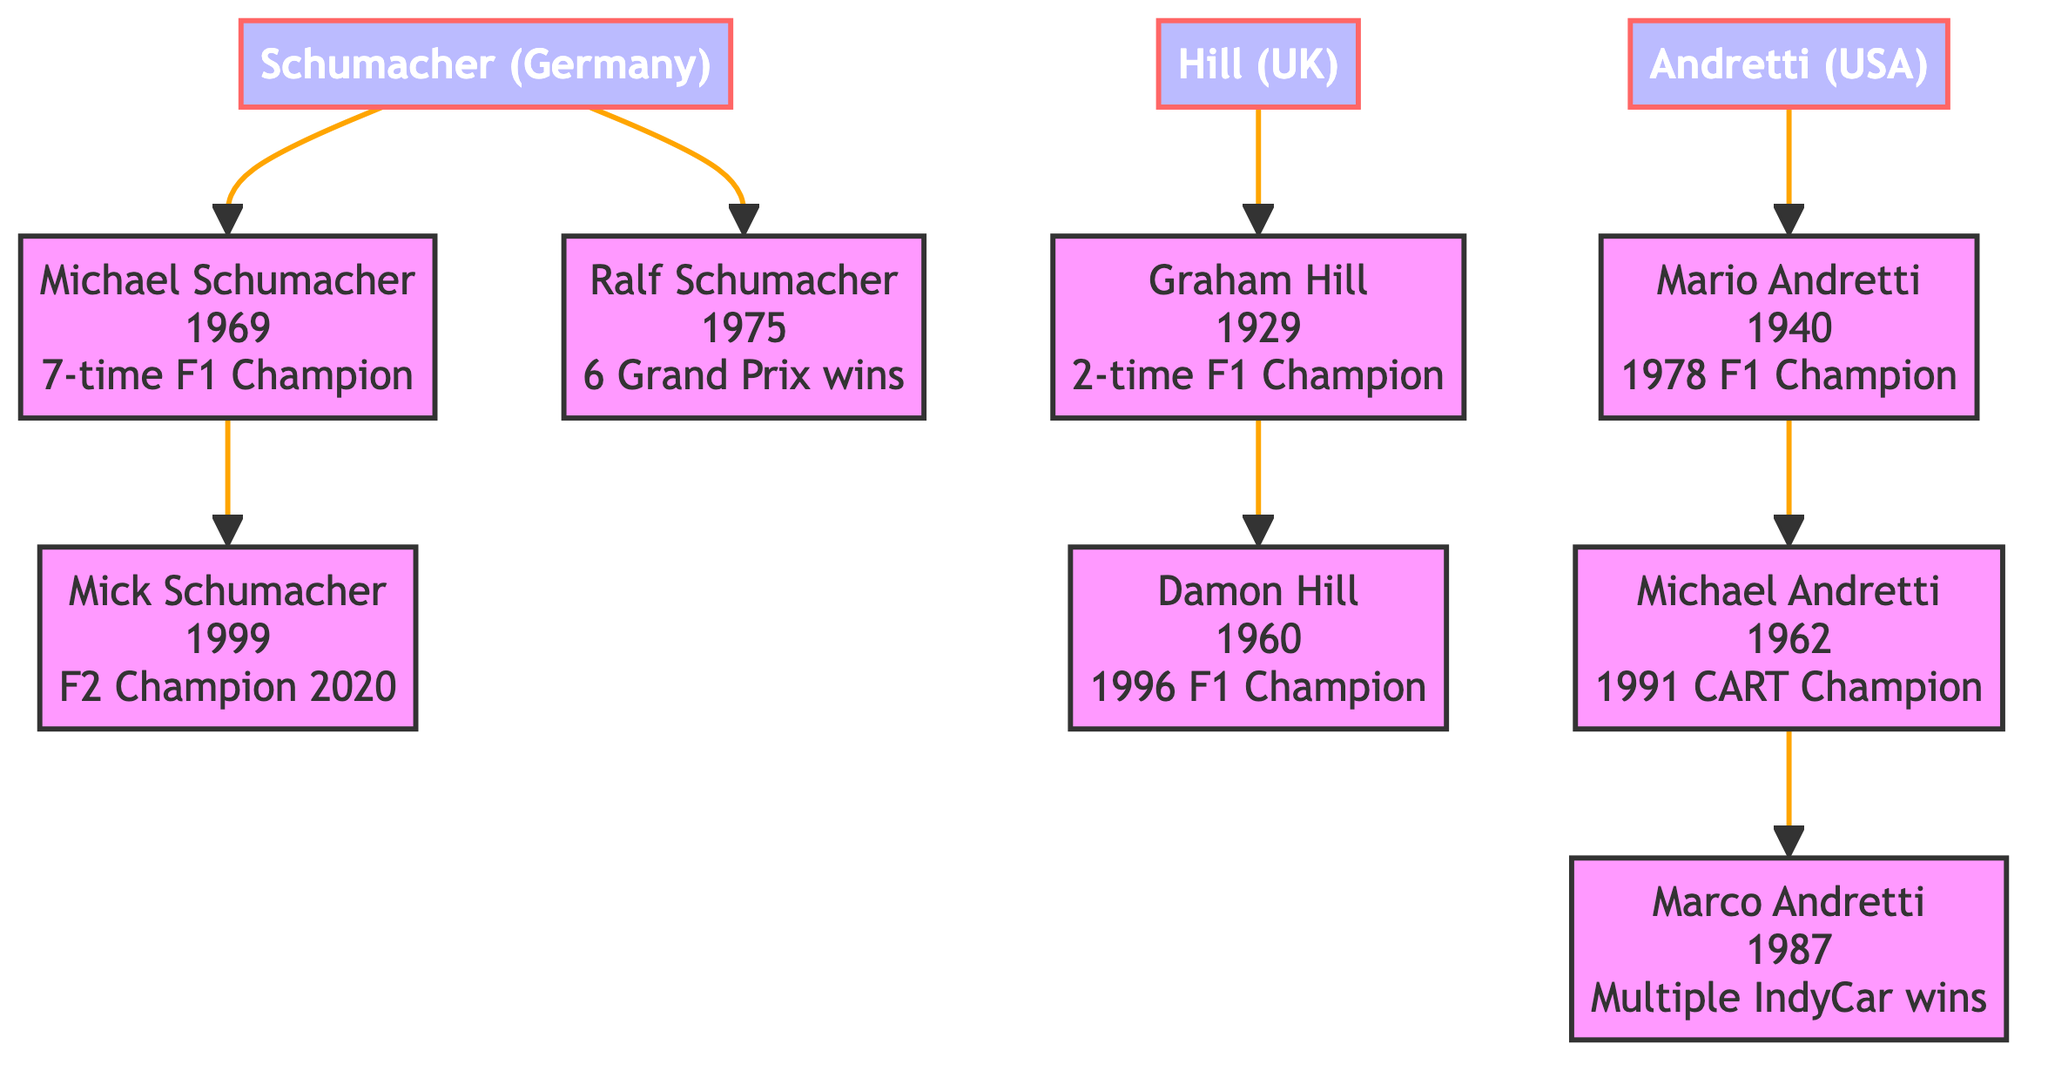What's the total number of families in the diagram? The diagram displays information about three distinct racing families: Schumacher, Hill, and Andretti. By counting these, we find there are three families.
Answer: 3 Who was the F1 champion in 1996? By following the Hill family branch in the diagram, we start with Graham Hill, and then find Damon Hill who is noted to be the 1996 Formula 1 World Champion.
Answer: Damon Hill How many Grand Prix wins does Ralf Schumacher have? The diagram indicates under Ralf Schumacher's contributions that he achieved 6 Grand Prix wins. Hence, the number of his wins is directly mentioned in the diagram.
Answer: 6 Which family does Mario Andretti belong to? Starting from the Andretti family node in the diagram, we can see that Mario Andretti is a member of this family. His contributions and achievements listed are also tied to this family.
Answer: Andretti What unique achievement is Graham Hill known for? The diagram states that Graham Hill is recognized for being the only driver to win the Triple Crown of Motorsport. We draw this information directly from his designated contributions in the diagram.
Answer: Triple Crown of Motorsport Which racing family has the most recent member mentioned? The member with the most recent birth year is Mick Schumacher, born in 1999. By examining all family branches, we find that he belongs to the Schumacher family.
Answer: Schumacher Which racing family does Michael Schumacher belong to? According to the diagram, Michael Schumacher is listed under the Schumacher family node, which makes it clear that he is part of that family.
Answer: Schumacher What year was Michael Andretti born? The diagram lists Michael Andretti's birth year as 1962, which we can find easily under his profile in the Andretti family branch.
Answer: 1962 How many World Champions are there in the Hill family? By reviewing the contributions of both members of the Hill family, Graham Hill and Damon Hill, it is noted that they each are a Formula 1 World Champion. Thus, there are two World Champions in this family.
Answer: 2 